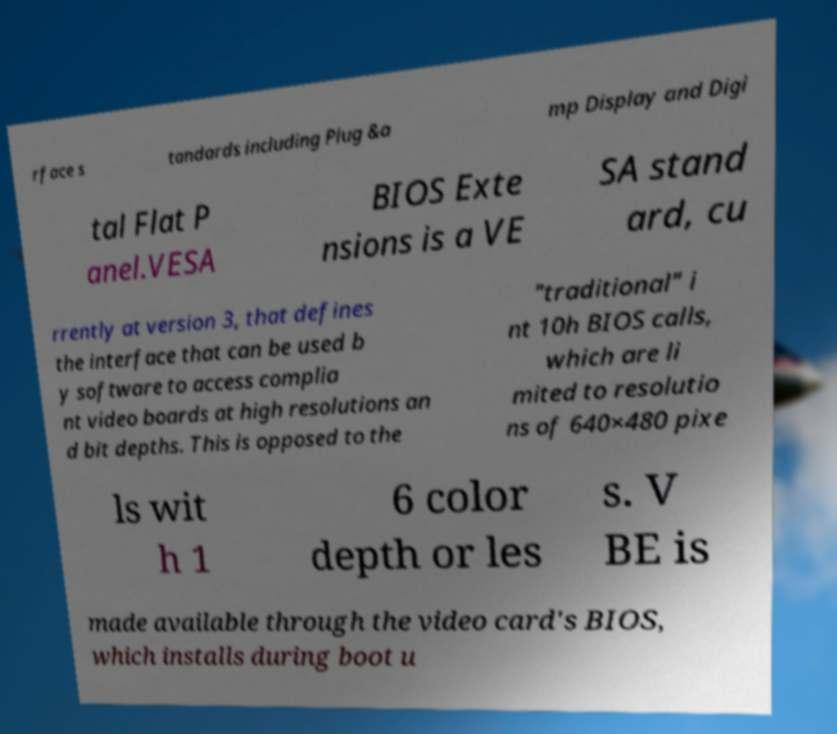For documentation purposes, I need the text within this image transcribed. Could you provide that? rface s tandards including Plug &a mp Display and Digi tal Flat P anel.VESA BIOS Exte nsions is a VE SA stand ard, cu rrently at version 3, that defines the interface that can be used b y software to access complia nt video boards at high resolutions an d bit depths. This is opposed to the "traditional" i nt 10h BIOS calls, which are li mited to resolutio ns of 640×480 pixe ls wit h 1 6 color depth or les s. V BE is made available through the video card's BIOS, which installs during boot u 